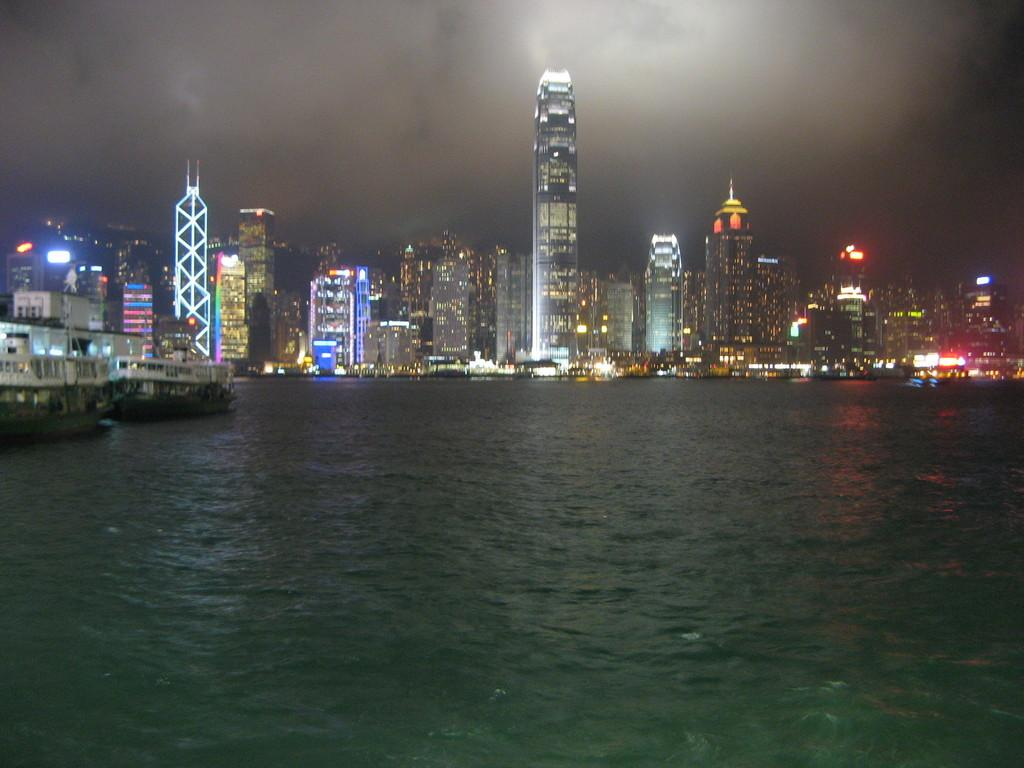What is the primary element in the image? There is water in the image. What is floating on the surface of the water? There are boats on the surface of the water. What structures can be seen in the image? There are buildings visible in the image. What type of illumination is present in the image? There are lights present in the image. What can be seen in the background of the image? The sky is visible in the background of the image. Where is the cactus located in the image? There is no cactus present in the image. What type of sky is depicted in the image? The provided facts do not specify the type of sky, only that the sky is visible in the background. Can you tell me how many mittens are being worn by the people in the image? There are no people or mittens present in the image. 